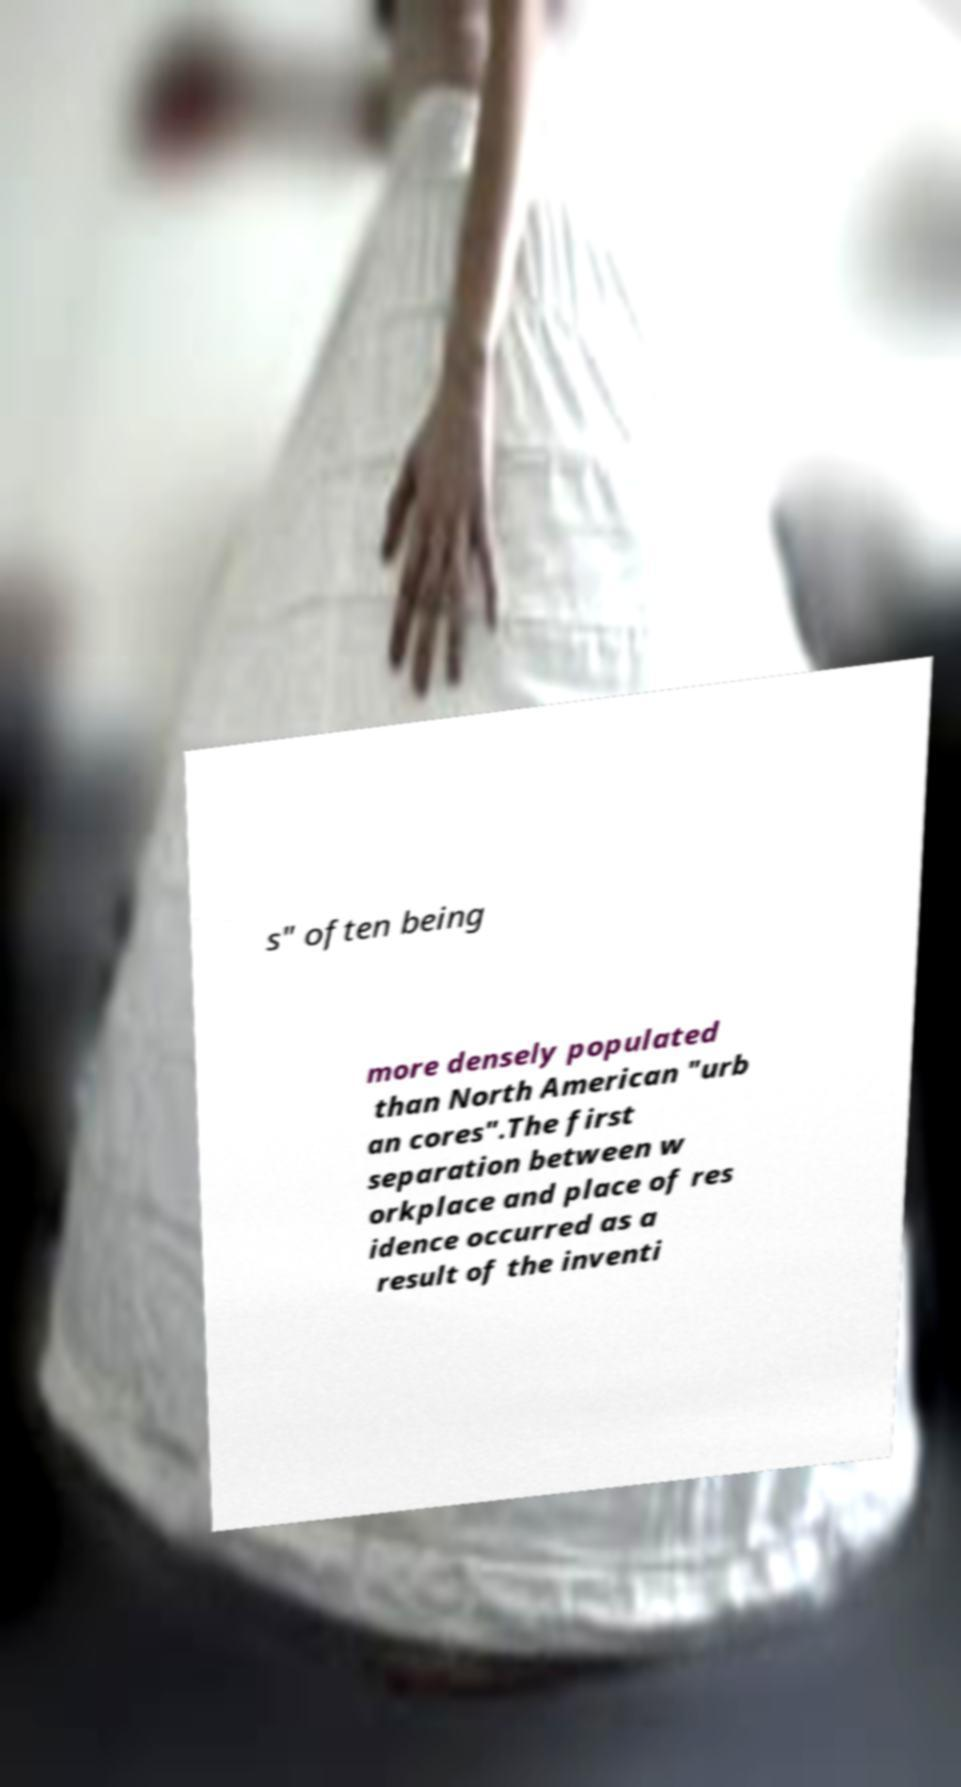Could you extract and type out the text from this image? s" often being more densely populated than North American "urb an cores".The first separation between w orkplace and place of res idence occurred as a result of the inventi 